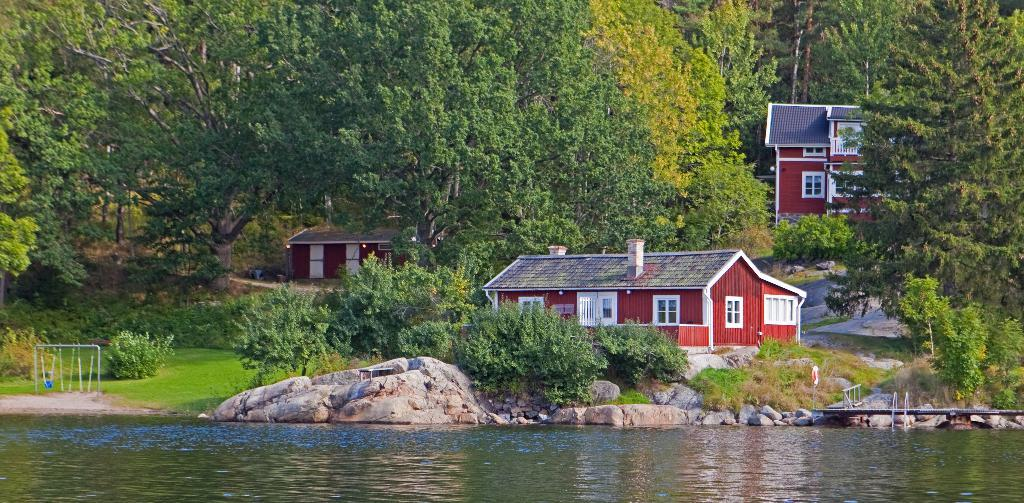What is located at the bottom of the image? There is a lake at the bottom of the image. What can be found near the lake? There are rocks near the lake. What structures are in the center of the image? There are sheds in the center of the image. What type of vegetation is visible in the background of the image? There are trees in the background of the image. Can you tell me how many buttons are floating on the lake in the image? There are no buttons present in the image; it features a lake with rocks near it. What type of hose is connected to the sheds in the image? There is no hose connected to the sheds in the image; only sheds, a lake, rocks, and trees are present. 